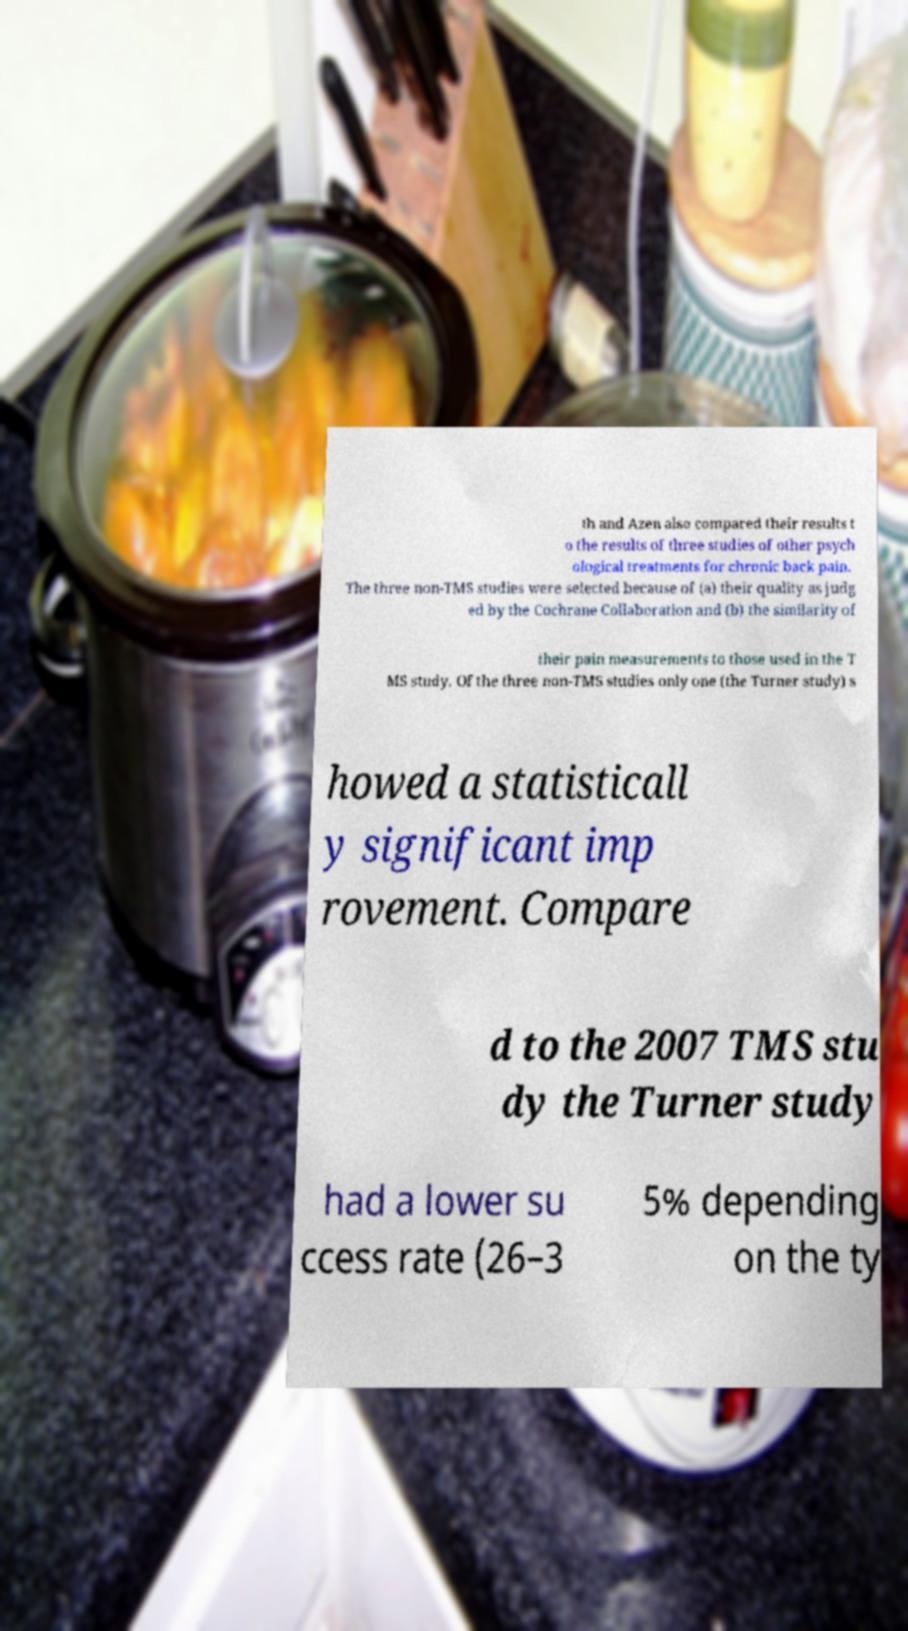Please identify and transcribe the text found in this image. th and Azen also compared their results t o the results of three studies of other psych ological treatments for chronic back pain. The three non-TMS studies were selected because of (a) their quality as judg ed by the Cochrane Collaboration and (b) the similarity of their pain measurements to those used in the T MS study. Of the three non-TMS studies only one (the Turner study) s howed a statisticall y significant imp rovement. Compare d to the 2007 TMS stu dy the Turner study had a lower su ccess rate (26–3 5% depending on the ty 